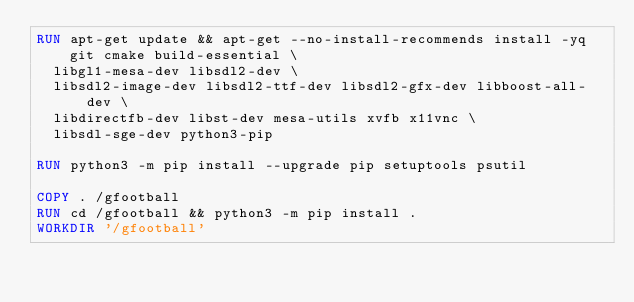Convert code to text. <code><loc_0><loc_0><loc_500><loc_500><_Dockerfile_>RUN apt-get update && apt-get --no-install-recommends install -yq git cmake build-essential \
  libgl1-mesa-dev libsdl2-dev \
  libsdl2-image-dev libsdl2-ttf-dev libsdl2-gfx-dev libboost-all-dev \
  libdirectfb-dev libst-dev mesa-utils xvfb x11vnc \
  libsdl-sge-dev python3-pip

RUN python3 -m pip install --upgrade pip setuptools psutil

COPY . /gfootball
RUN cd /gfootball && python3 -m pip install .
WORKDIR '/gfootball'
</code> 